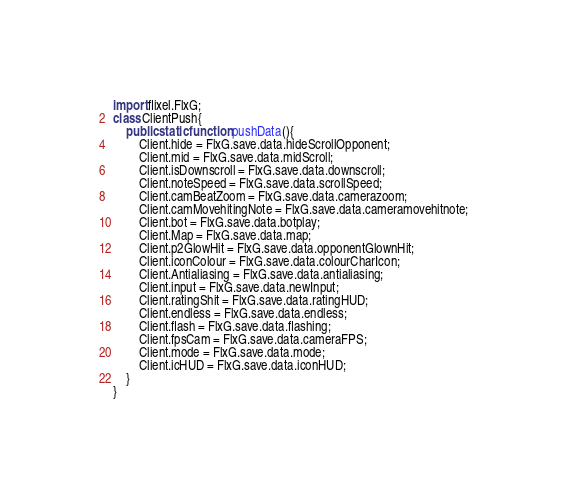Convert code to text. <code><loc_0><loc_0><loc_500><loc_500><_Haxe_>import flixel.FlxG;
class ClientPush{
    public static function pushData(){
        Client.hide = FlxG.save.data.hideScrollOpponent;
        Client.mid = FlxG.save.data.midScroll;
        Client.isDownscroll = FlxG.save.data.downscroll;
        Client.noteSpeed = FlxG.save.data.scrollSpeed;
        Client.camBeatZoom = FlxG.save.data.camerazoom;
        Client.camMovehitingNote = FlxG.save.data.cameramovehitnote;
        Client.bot = FlxG.save.data.botplay;
        Client.Map = FlxG.save.data.map;
        Client.p2GlowHit = FlxG.save.data.opponentGlownHit;
        Client.iconColour = FlxG.save.data.colourCharIcon;
        Client.Antialiasing = FlxG.save.data.antialiasing;
        Client.input = FlxG.save.data.newInput;
        Client.ratingShit = FlxG.save.data.ratingHUD;
        Client.endless = FlxG.save.data.endless;
        Client.flash = FlxG.save.data.flashing;
        Client.fpsCam = FlxG.save.data.cameraFPS;
        Client.mode = FlxG.save.data.mode;
        Client.icHUD = FlxG.save.data.iconHUD;
    }
}</code> 